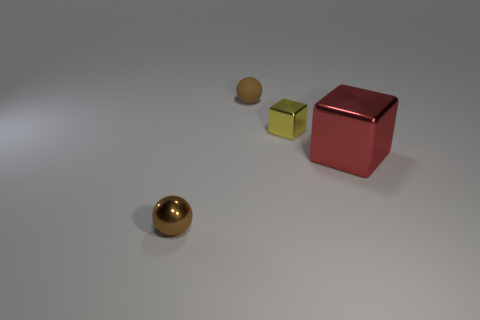Add 2 tiny metal cubes. How many objects exist? 6 Add 4 green things. How many green things exist? 4 Subtract 0 gray blocks. How many objects are left? 4 Subtract all small gray shiny spheres. Subtract all brown things. How many objects are left? 2 Add 2 brown things. How many brown things are left? 4 